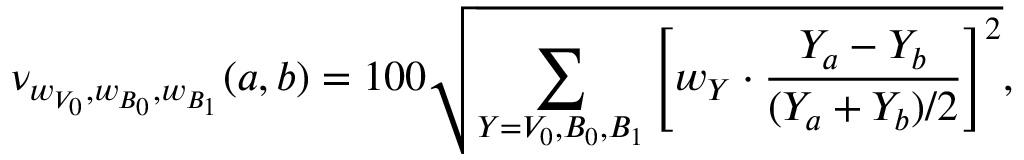<formula> <loc_0><loc_0><loc_500><loc_500>\nu _ { w _ { V _ { 0 } } , w _ { B _ { 0 } } , w _ { B _ { 1 } } } ( a , b ) = 1 0 0 \sqrt { \sum _ { Y = V _ { 0 } , B _ { 0 } , B _ { 1 } } \left [ w _ { Y } \cdot \frac { Y _ { a } - Y _ { b } } { ( Y _ { a } + Y _ { b } ) / 2 } \right ] ^ { 2 } } ,</formula> 